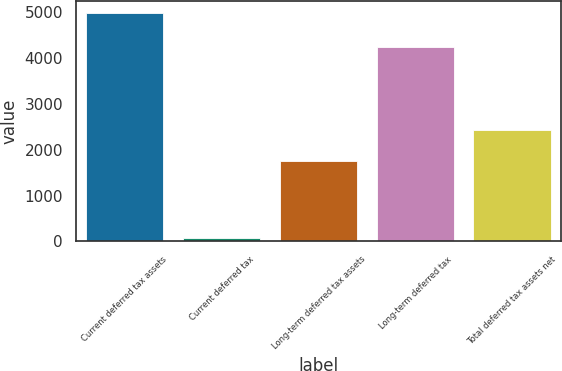Convert chart to OTSL. <chart><loc_0><loc_0><loc_500><loc_500><bar_chart><fcel>Current deferred tax assets<fcel>Current deferred tax<fcel>Long-term deferred tax assets<fcel>Long-term deferred tax<fcel>Total deferred tax assets net<nl><fcel>4979<fcel>83<fcel>1751<fcel>4230<fcel>2417<nl></chart> 